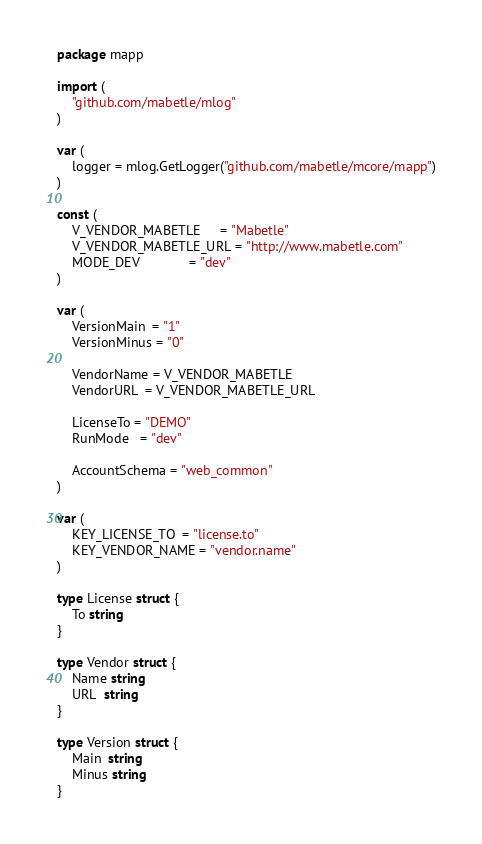Convert code to text. <code><loc_0><loc_0><loc_500><loc_500><_Go_>package mapp

import (
	"github.com/mabetle/mlog"
)

var (
	logger = mlog.GetLogger("github.com/mabetle/mcore/mapp")
)

const (
	V_VENDOR_MABETLE     = "Mabetle"
	V_VENDOR_MABETLE_URL = "http://www.mabetle.com"
	MODE_DEV             = "dev"
)

var (
	VersionMain  = "1"
	VersionMinus = "0"

	VendorName = V_VENDOR_MABETLE
	VendorURL  = V_VENDOR_MABETLE_URL

	LicenseTo = "DEMO"
	RunMode   = "dev"

	AccountSchema = "web_common"
)

var (
	KEY_LICENSE_TO  = "license.to"
	KEY_VENDOR_NAME = "vendor.name"
)

type License struct {
	To string
}

type Vendor struct {
	Name string
	URL  string
}

type Version struct {
	Main  string
	Minus string
}
</code> 